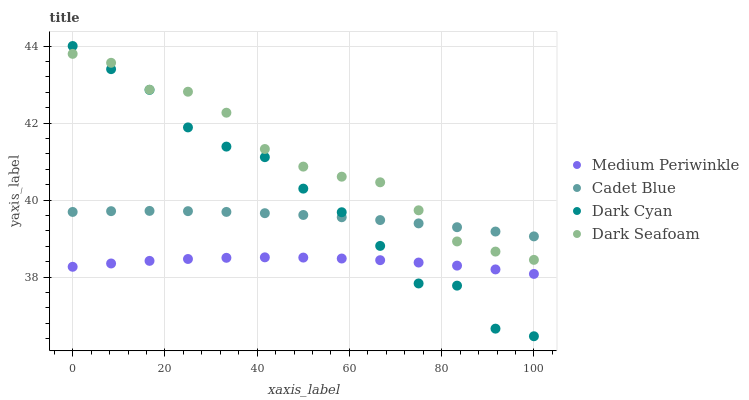Does Medium Periwinkle have the minimum area under the curve?
Answer yes or no. Yes. Does Dark Seafoam have the maximum area under the curve?
Answer yes or no. Yes. Does Cadet Blue have the minimum area under the curve?
Answer yes or no. No. Does Cadet Blue have the maximum area under the curve?
Answer yes or no. No. Is Cadet Blue the smoothest?
Answer yes or no. Yes. Is Dark Cyan the roughest?
Answer yes or no. Yes. Is Dark Seafoam the smoothest?
Answer yes or no. No. Is Dark Seafoam the roughest?
Answer yes or no. No. Does Dark Cyan have the lowest value?
Answer yes or no. Yes. Does Dark Seafoam have the lowest value?
Answer yes or no. No. Does Dark Cyan have the highest value?
Answer yes or no. Yes. Does Dark Seafoam have the highest value?
Answer yes or no. No. Is Medium Periwinkle less than Dark Seafoam?
Answer yes or no. Yes. Is Cadet Blue greater than Medium Periwinkle?
Answer yes or no. Yes. Does Cadet Blue intersect Dark Cyan?
Answer yes or no. Yes. Is Cadet Blue less than Dark Cyan?
Answer yes or no. No. Is Cadet Blue greater than Dark Cyan?
Answer yes or no. No. Does Medium Periwinkle intersect Dark Seafoam?
Answer yes or no. No. 